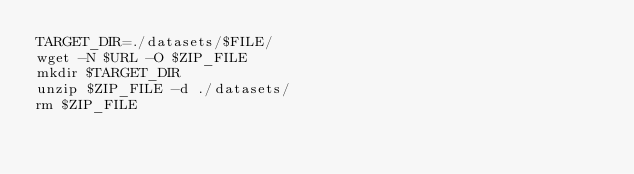Convert code to text. <code><loc_0><loc_0><loc_500><loc_500><_Bash_>TARGET_DIR=./datasets/$FILE/
wget -N $URL -O $ZIP_FILE
mkdir $TARGET_DIR
unzip $ZIP_FILE -d ./datasets/
rm $ZIP_FILE
</code> 